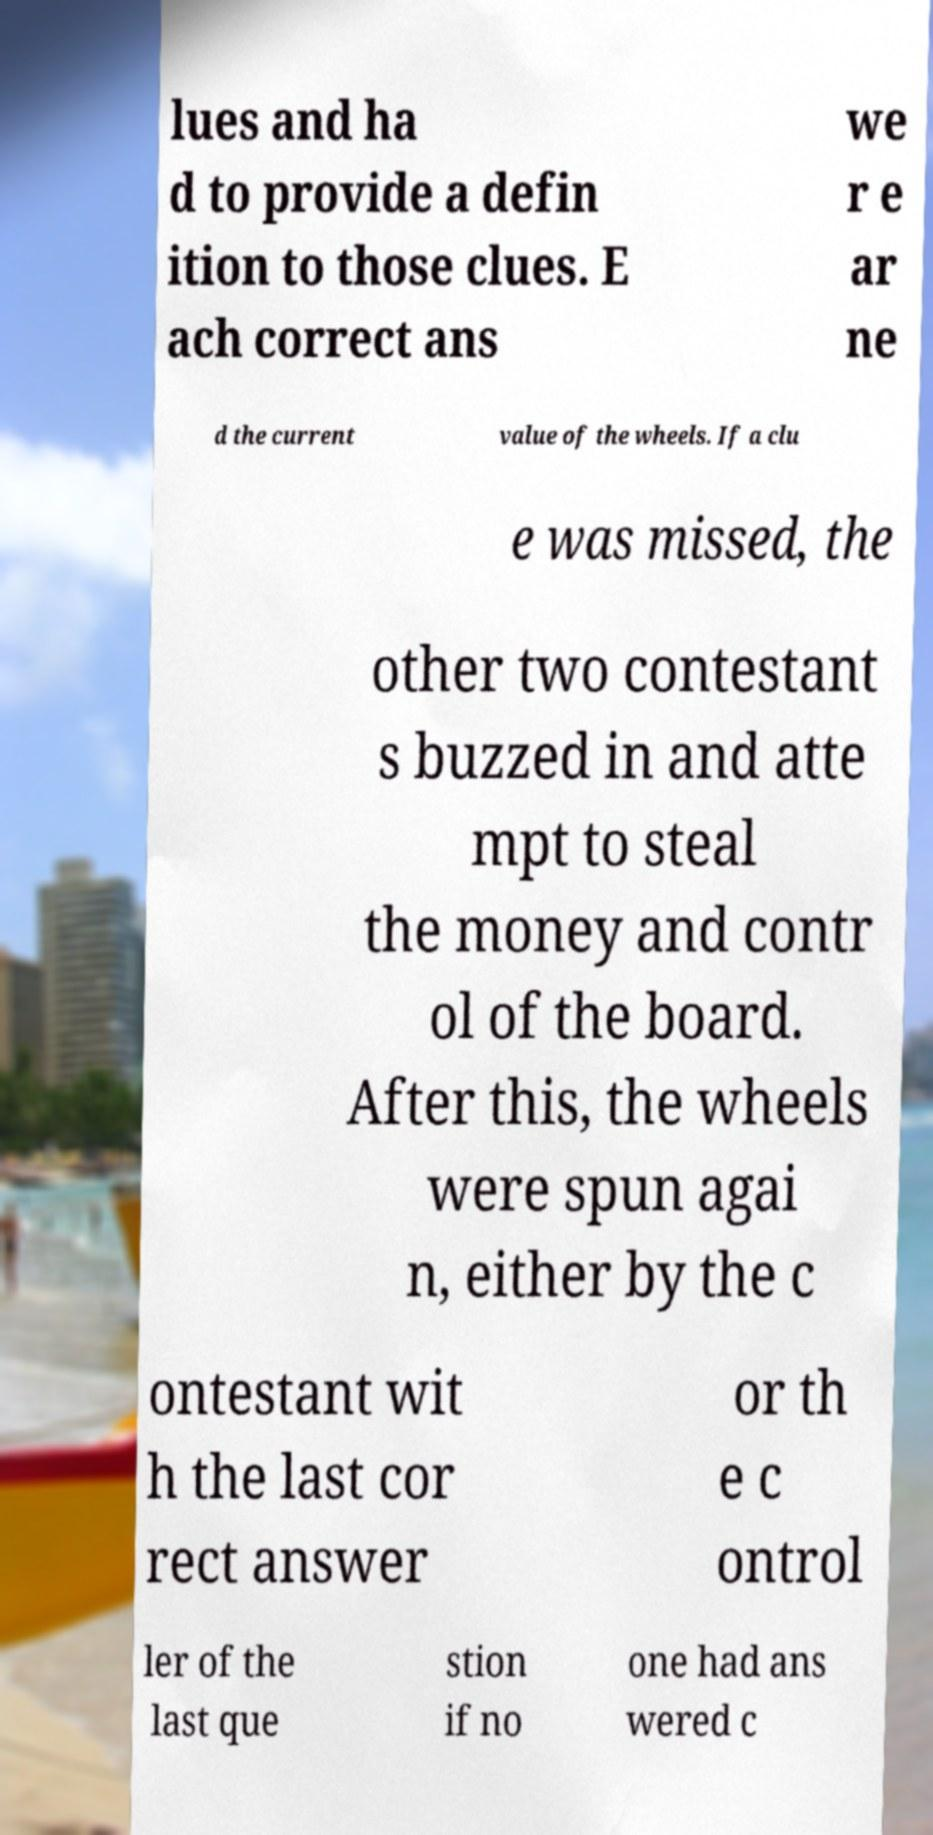What messages or text are displayed in this image? I need them in a readable, typed format. lues and ha d to provide a defin ition to those clues. E ach correct ans we r e ar ne d the current value of the wheels. If a clu e was missed, the other two contestant s buzzed in and atte mpt to steal the money and contr ol of the board. After this, the wheels were spun agai n, either by the c ontestant wit h the last cor rect answer or th e c ontrol ler of the last que stion if no one had ans wered c 